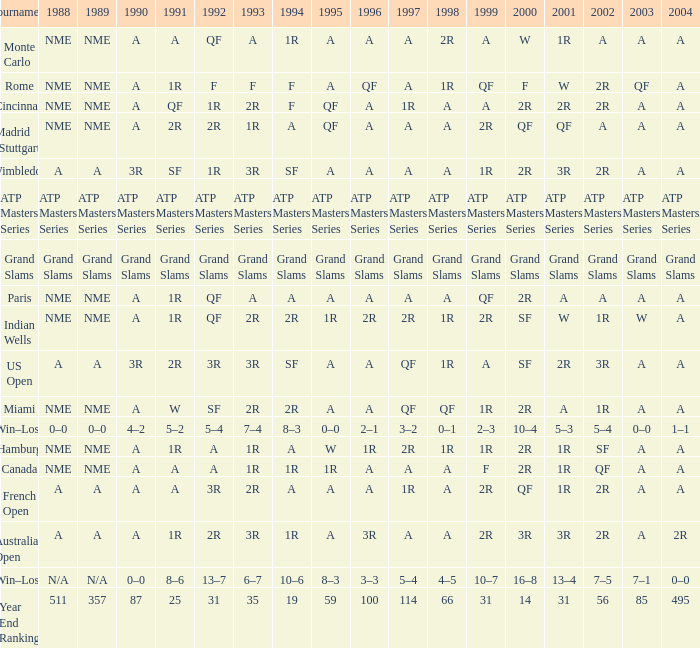What shows for 1995 when 1996 shows grand slams? Grand Slams. 